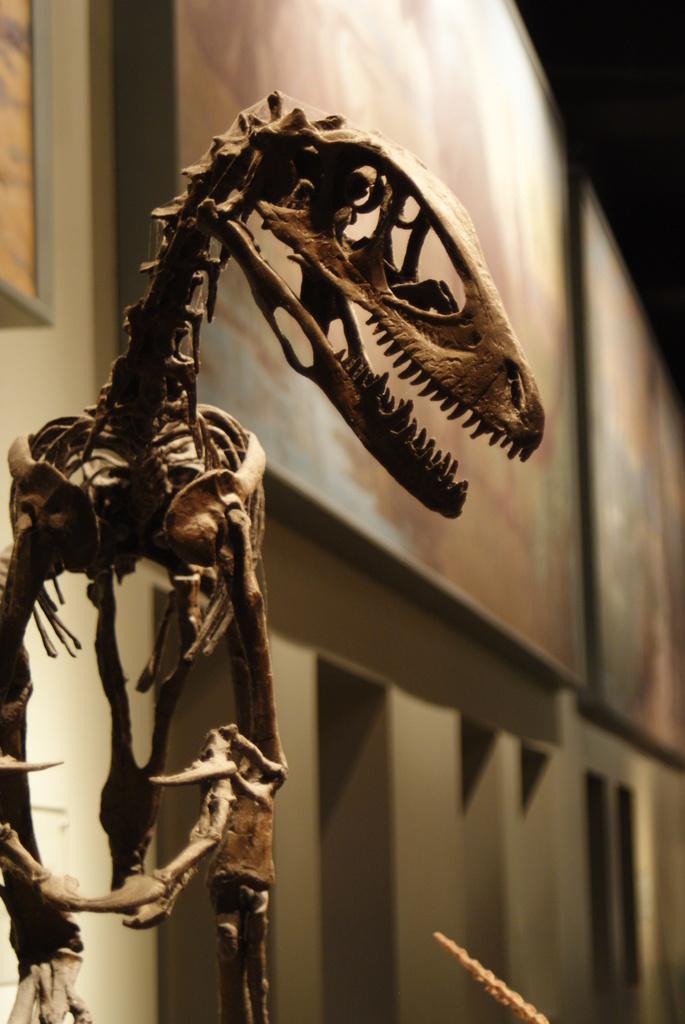In one or two sentences, can you explain what this image depicts? In this image we can see skeleton, boards, and wall. 